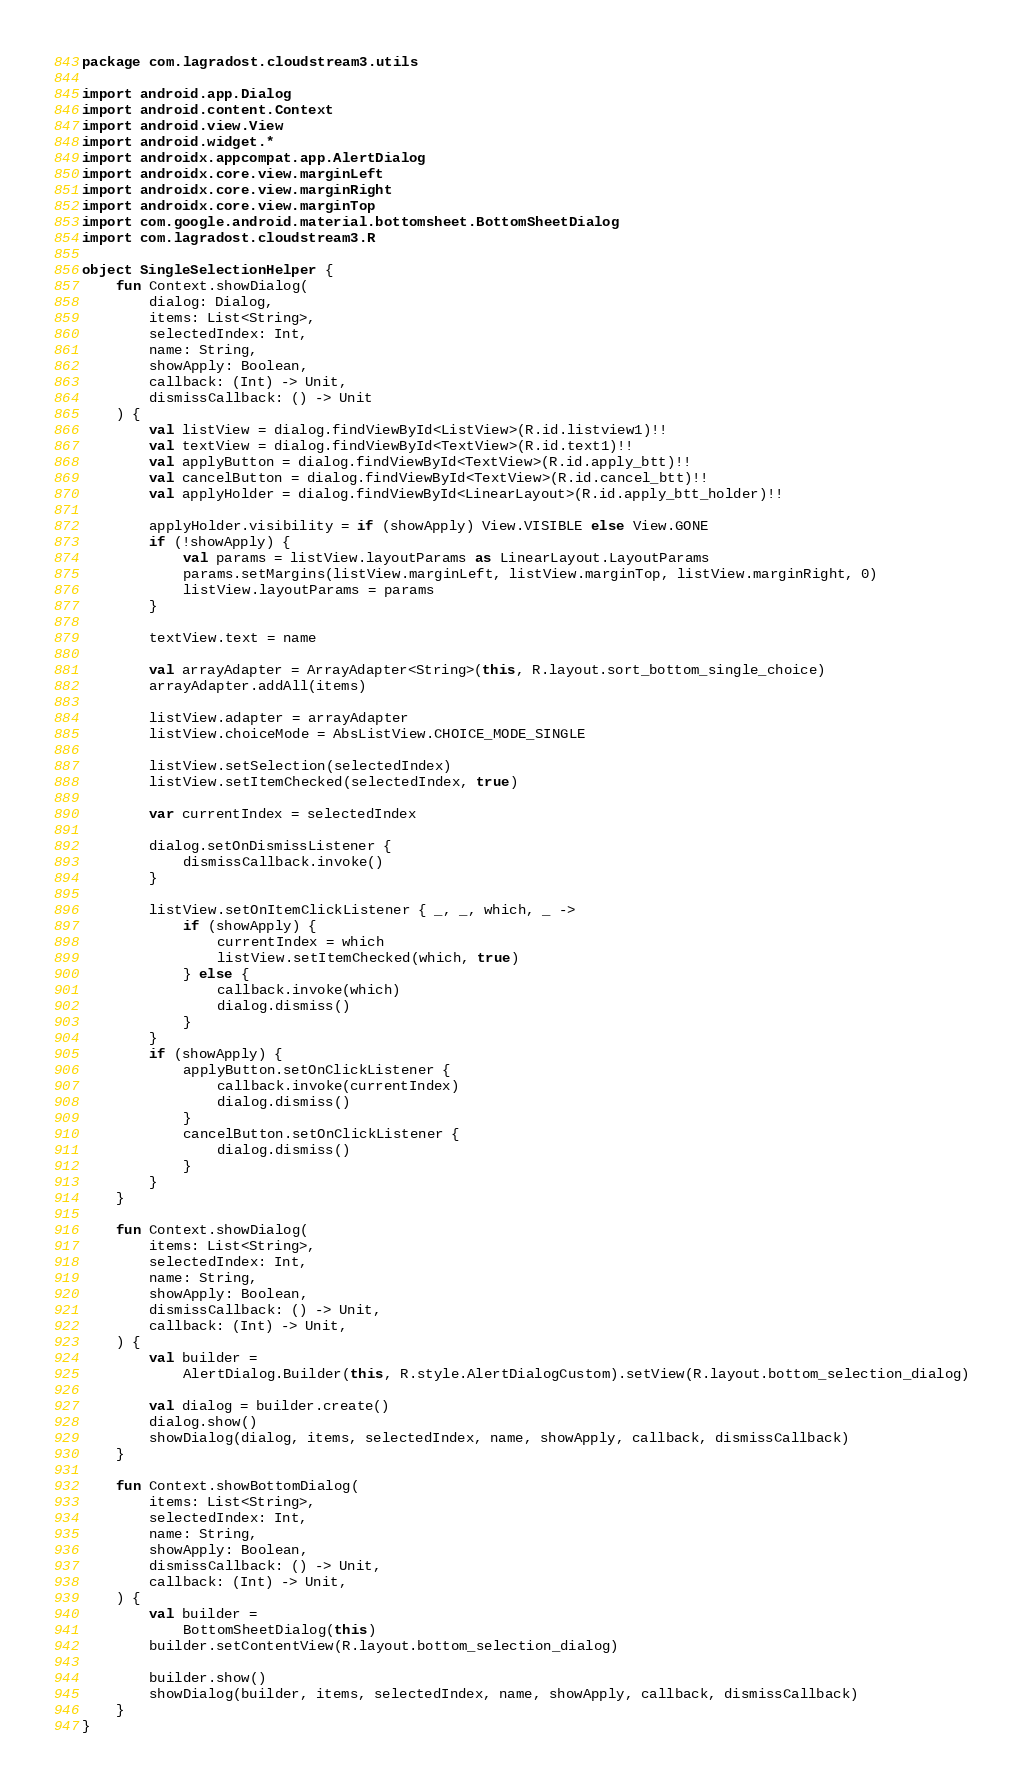<code> <loc_0><loc_0><loc_500><loc_500><_Kotlin_>package com.lagradost.cloudstream3.utils

import android.app.Dialog
import android.content.Context
import android.view.View
import android.widget.*
import androidx.appcompat.app.AlertDialog
import androidx.core.view.marginLeft
import androidx.core.view.marginRight
import androidx.core.view.marginTop
import com.google.android.material.bottomsheet.BottomSheetDialog
import com.lagradost.cloudstream3.R

object SingleSelectionHelper {
    fun Context.showDialog(
        dialog: Dialog,
        items: List<String>,
        selectedIndex: Int,
        name: String,
        showApply: Boolean,
        callback: (Int) -> Unit,
        dismissCallback: () -> Unit
    ) {
        val listView = dialog.findViewById<ListView>(R.id.listview1)!!
        val textView = dialog.findViewById<TextView>(R.id.text1)!!
        val applyButton = dialog.findViewById<TextView>(R.id.apply_btt)!!
        val cancelButton = dialog.findViewById<TextView>(R.id.cancel_btt)!!
        val applyHolder = dialog.findViewById<LinearLayout>(R.id.apply_btt_holder)!!

        applyHolder.visibility = if (showApply) View.VISIBLE else View.GONE
        if (!showApply) {
            val params = listView.layoutParams as LinearLayout.LayoutParams
            params.setMargins(listView.marginLeft, listView.marginTop, listView.marginRight, 0)
            listView.layoutParams = params
        }

        textView.text = name

        val arrayAdapter = ArrayAdapter<String>(this, R.layout.sort_bottom_single_choice)
        arrayAdapter.addAll(items)

        listView.adapter = arrayAdapter
        listView.choiceMode = AbsListView.CHOICE_MODE_SINGLE

        listView.setSelection(selectedIndex)
        listView.setItemChecked(selectedIndex, true)

        var currentIndex = selectedIndex

        dialog.setOnDismissListener {
            dismissCallback.invoke()
        }

        listView.setOnItemClickListener { _, _, which, _ ->
            if (showApply) {
                currentIndex = which
                listView.setItemChecked(which, true)
            } else {
                callback.invoke(which)
                dialog.dismiss()
            }
        }
        if (showApply) {
            applyButton.setOnClickListener {
                callback.invoke(currentIndex)
                dialog.dismiss()
            }
            cancelButton.setOnClickListener {
                dialog.dismiss()
            }
        }
    }

    fun Context.showDialog(
        items: List<String>,
        selectedIndex: Int,
        name: String,
        showApply: Boolean,
        dismissCallback: () -> Unit,
        callback: (Int) -> Unit,
    ) {
        val builder =
            AlertDialog.Builder(this, R.style.AlertDialogCustom).setView(R.layout.bottom_selection_dialog)

        val dialog = builder.create()
        dialog.show()
        showDialog(dialog, items, selectedIndex, name, showApply, callback, dismissCallback)
    }

    fun Context.showBottomDialog(
        items: List<String>,
        selectedIndex: Int,
        name: String,
        showApply: Boolean,
        dismissCallback: () -> Unit,
        callback: (Int) -> Unit,
    ) {
        val builder =
            BottomSheetDialog(this)
        builder.setContentView(R.layout.bottom_selection_dialog)

        builder.show()
        showDialog(builder, items, selectedIndex, name, showApply, callback, dismissCallback)
    }
}</code> 